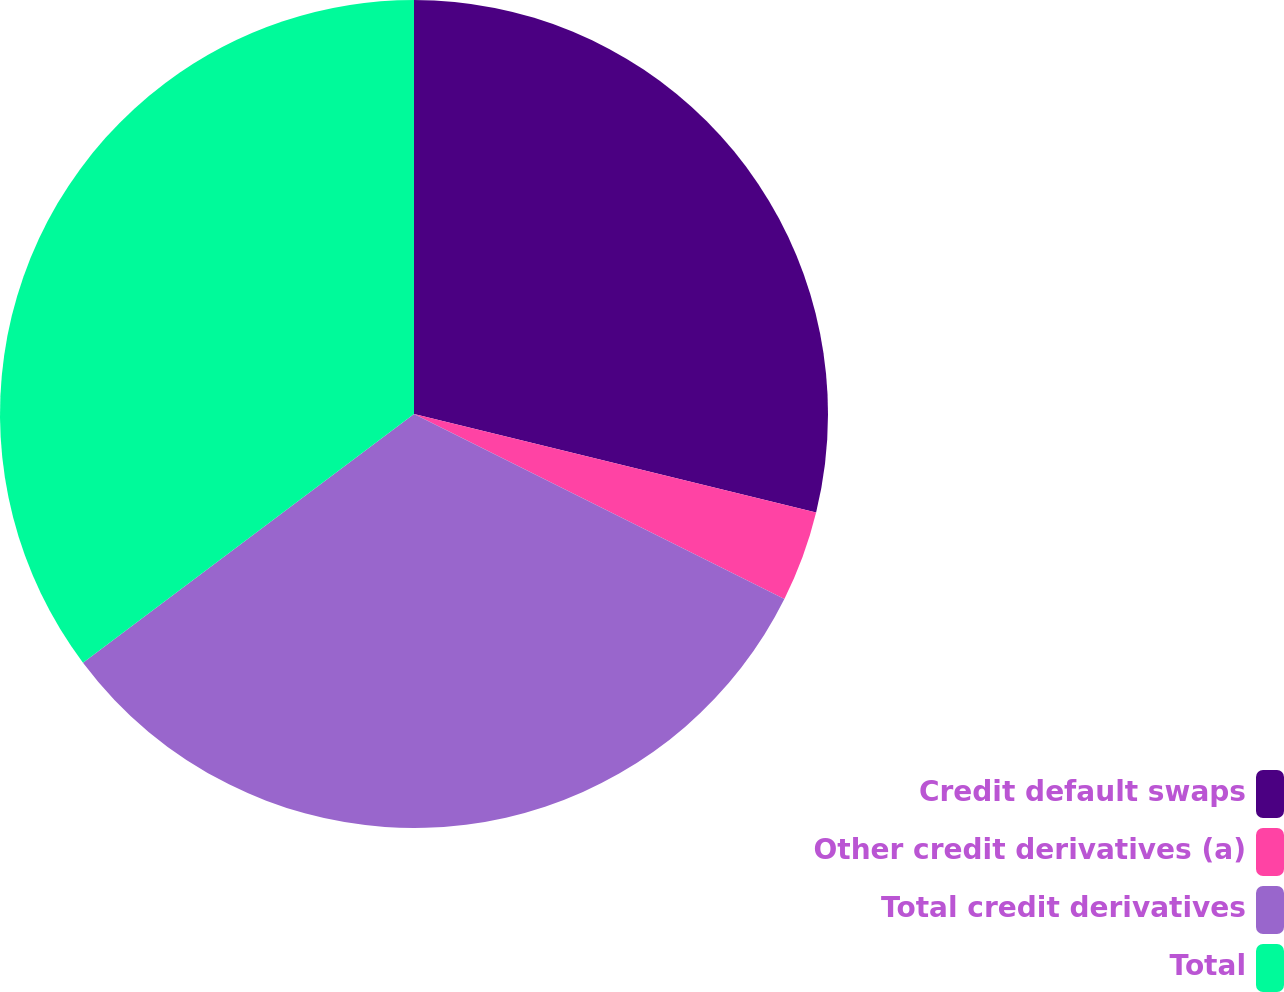<chart> <loc_0><loc_0><loc_500><loc_500><pie_chart><fcel>Credit default swaps<fcel>Other credit derivatives (a)<fcel>Total credit derivatives<fcel>Total<nl><fcel>28.82%<fcel>3.55%<fcel>32.37%<fcel>35.25%<nl></chart> 